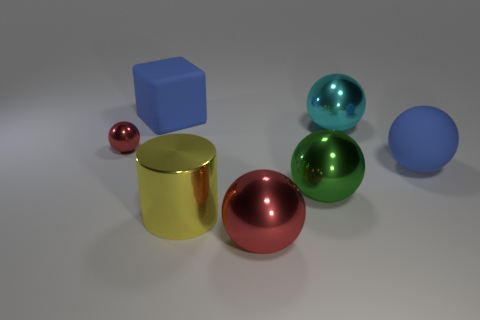There is a thing that is on the left side of the yellow cylinder and in front of the large cyan thing; what is its material?
Your answer should be very brief. Metal. What is the color of the big sphere on the right side of the shiny ball to the right of the green ball?
Offer a very short reply. Blue. There is a green object that is the same shape as the large cyan thing; what material is it?
Offer a terse response. Metal. There is a matte object that is behind the big blue matte thing in front of the big blue thing on the left side of the cyan shiny thing; what is its color?
Provide a succinct answer. Blue. What number of objects are tiny red metallic objects or big metallic balls?
Ensure brevity in your answer.  4. How many large blue things have the same shape as the green shiny thing?
Provide a short and direct response. 1. Does the large cylinder have the same material as the big blue thing that is to the left of the big red shiny sphere?
Keep it short and to the point. No. There is a cylinder that is made of the same material as the cyan object; what is its size?
Offer a terse response. Large. How big is the rubber thing that is to the left of the large cyan object?
Ensure brevity in your answer.  Large. How many brown cylinders are the same size as the blue block?
Provide a short and direct response. 0. 